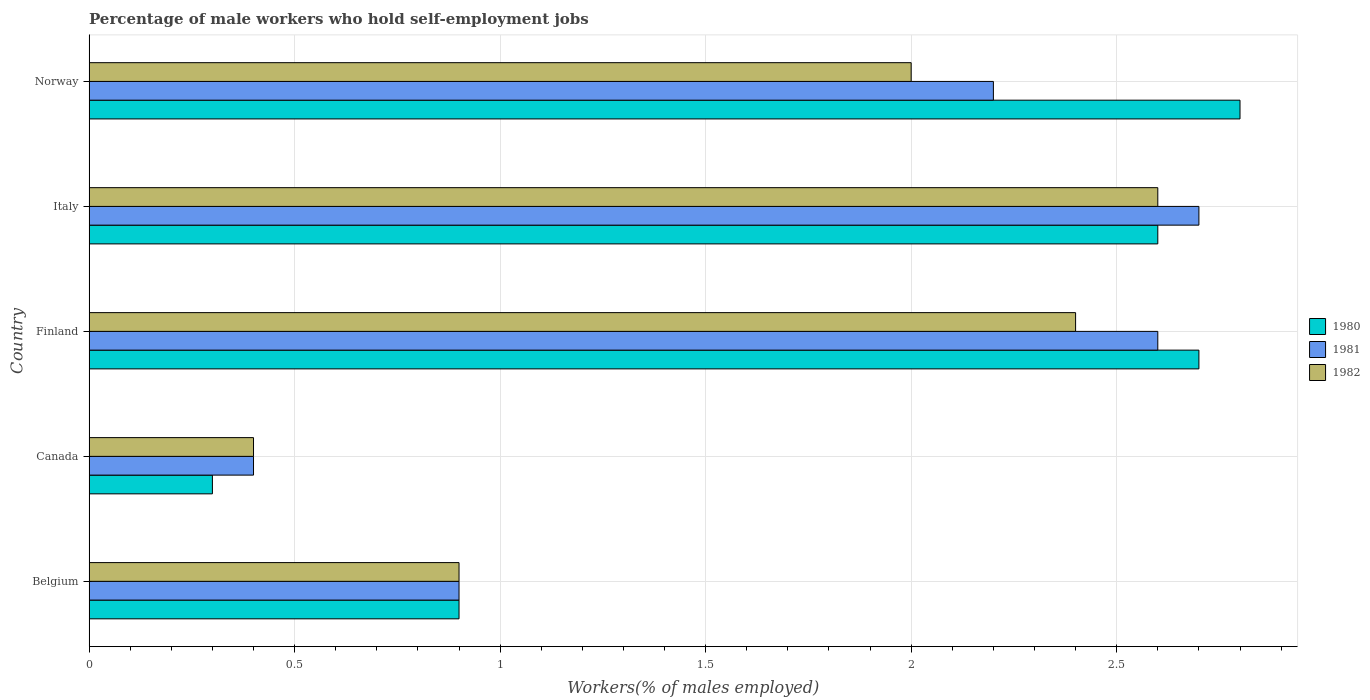How many different coloured bars are there?
Keep it short and to the point. 3. How many groups of bars are there?
Provide a succinct answer. 5. How many bars are there on the 2nd tick from the top?
Offer a terse response. 3. What is the label of the 5th group of bars from the top?
Provide a succinct answer. Belgium. What is the percentage of self-employed male workers in 1982 in Belgium?
Provide a short and direct response. 0.9. Across all countries, what is the maximum percentage of self-employed male workers in 1982?
Provide a succinct answer. 2.6. Across all countries, what is the minimum percentage of self-employed male workers in 1980?
Keep it short and to the point. 0.3. What is the total percentage of self-employed male workers in 1981 in the graph?
Your response must be concise. 8.8. What is the difference between the percentage of self-employed male workers in 1982 in Belgium and that in Norway?
Provide a succinct answer. -1.1. What is the difference between the percentage of self-employed male workers in 1980 in Canada and the percentage of self-employed male workers in 1981 in Belgium?
Your response must be concise. -0.6. What is the average percentage of self-employed male workers in 1980 per country?
Give a very brief answer. 1.86. What is the difference between the percentage of self-employed male workers in 1980 and percentage of self-employed male workers in 1982 in Italy?
Ensure brevity in your answer.  0. What is the ratio of the percentage of self-employed male workers in 1982 in Canada to that in Finland?
Offer a very short reply. 0.17. Is the percentage of self-employed male workers in 1982 in Belgium less than that in Norway?
Provide a short and direct response. Yes. What is the difference between the highest and the second highest percentage of self-employed male workers in 1980?
Ensure brevity in your answer.  0.1. What is the difference between the highest and the lowest percentage of self-employed male workers in 1980?
Ensure brevity in your answer.  2.5. What does the 3rd bar from the top in Norway represents?
Ensure brevity in your answer.  1980. Is it the case that in every country, the sum of the percentage of self-employed male workers in 1980 and percentage of self-employed male workers in 1982 is greater than the percentage of self-employed male workers in 1981?
Offer a very short reply. Yes. How many countries are there in the graph?
Make the answer very short. 5. Are the values on the major ticks of X-axis written in scientific E-notation?
Your answer should be compact. No. Does the graph contain any zero values?
Make the answer very short. No. What is the title of the graph?
Provide a short and direct response. Percentage of male workers who hold self-employment jobs. What is the label or title of the X-axis?
Provide a succinct answer. Workers(% of males employed). What is the Workers(% of males employed) of 1980 in Belgium?
Give a very brief answer. 0.9. What is the Workers(% of males employed) in 1981 in Belgium?
Your answer should be compact. 0.9. What is the Workers(% of males employed) in 1982 in Belgium?
Provide a short and direct response. 0.9. What is the Workers(% of males employed) of 1980 in Canada?
Your answer should be compact. 0.3. What is the Workers(% of males employed) of 1981 in Canada?
Keep it short and to the point. 0.4. What is the Workers(% of males employed) of 1982 in Canada?
Give a very brief answer. 0.4. What is the Workers(% of males employed) of 1980 in Finland?
Offer a terse response. 2.7. What is the Workers(% of males employed) in 1981 in Finland?
Offer a terse response. 2.6. What is the Workers(% of males employed) in 1982 in Finland?
Keep it short and to the point. 2.4. What is the Workers(% of males employed) in 1980 in Italy?
Provide a short and direct response. 2.6. What is the Workers(% of males employed) in 1981 in Italy?
Your answer should be compact. 2.7. What is the Workers(% of males employed) in 1982 in Italy?
Your response must be concise. 2.6. What is the Workers(% of males employed) in 1980 in Norway?
Ensure brevity in your answer.  2.8. What is the Workers(% of males employed) in 1981 in Norway?
Make the answer very short. 2.2. What is the Workers(% of males employed) in 1982 in Norway?
Provide a short and direct response. 2. Across all countries, what is the maximum Workers(% of males employed) of 1980?
Your answer should be very brief. 2.8. Across all countries, what is the maximum Workers(% of males employed) of 1981?
Offer a terse response. 2.7. Across all countries, what is the maximum Workers(% of males employed) of 1982?
Ensure brevity in your answer.  2.6. Across all countries, what is the minimum Workers(% of males employed) of 1980?
Your answer should be very brief. 0.3. Across all countries, what is the minimum Workers(% of males employed) in 1981?
Your answer should be very brief. 0.4. Across all countries, what is the minimum Workers(% of males employed) of 1982?
Ensure brevity in your answer.  0.4. What is the total Workers(% of males employed) of 1981 in the graph?
Ensure brevity in your answer.  8.8. What is the total Workers(% of males employed) of 1982 in the graph?
Keep it short and to the point. 8.3. What is the difference between the Workers(% of males employed) of 1981 in Belgium and that in Canada?
Keep it short and to the point. 0.5. What is the difference between the Workers(% of males employed) in 1981 in Belgium and that in Finland?
Your answer should be compact. -1.7. What is the difference between the Workers(% of males employed) of 1982 in Belgium and that in Italy?
Ensure brevity in your answer.  -1.7. What is the difference between the Workers(% of males employed) of 1980 in Belgium and that in Norway?
Give a very brief answer. -1.9. What is the difference between the Workers(% of males employed) in 1982 in Belgium and that in Norway?
Provide a succinct answer. -1.1. What is the difference between the Workers(% of males employed) of 1980 in Canada and that in Finland?
Your answer should be very brief. -2.4. What is the difference between the Workers(% of males employed) of 1981 in Canada and that in Finland?
Give a very brief answer. -2.2. What is the difference between the Workers(% of males employed) in 1982 in Canada and that in Finland?
Your answer should be compact. -2. What is the difference between the Workers(% of males employed) of 1980 in Canada and that in Italy?
Your response must be concise. -2.3. What is the difference between the Workers(% of males employed) of 1982 in Canada and that in Italy?
Provide a succinct answer. -2.2. What is the difference between the Workers(% of males employed) in 1980 in Canada and that in Norway?
Offer a terse response. -2.5. What is the difference between the Workers(% of males employed) in 1980 in Finland and that in Italy?
Provide a succinct answer. 0.1. What is the difference between the Workers(% of males employed) in 1981 in Finland and that in Italy?
Provide a short and direct response. -0.1. What is the difference between the Workers(% of males employed) of 1982 in Finland and that in Italy?
Provide a succinct answer. -0.2. What is the difference between the Workers(% of males employed) of 1980 in Finland and that in Norway?
Your response must be concise. -0.1. What is the difference between the Workers(% of males employed) of 1982 in Finland and that in Norway?
Provide a short and direct response. 0.4. What is the difference between the Workers(% of males employed) in 1980 in Belgium and the Workers(% of males employed) in 1982 in Canada?
Provide a succinct answer. 0.5. What is the difference between the Workers(% of males employed) of 1981 in Belgium and the Workers(% of males employed) of 1982 in Canada?
Your answer should be very brief. 0.5. What is the difference between the Workers(% of males employed) in 1980 in Belgium and the Workers(% of males employed) in 1981 in Norway?
Offer a terse response. -1.3. What is the difference between the Workers(% of males employed) of 1981 in Belgium and the Workers(% of males employed) of 1982 in Norway?
Your answer should be very brief. -1.1. What is the difference between the Workers(% of males employed) in 1980 in Canada and the Workers(% of males employed) in 1982 in Finland?
Offer a terse response. -2.1. What is the difference between the Workers(% of males employed) of 1981 in Canada and the Workers(% of males employed) of 1982 in Finland?
Offer a terse response. -2. What is the difference between the Workers(% of males employed) of 1981 in Canada and the Workers(% of males employed) of 1982 in Italy?
Offer a terse response. -2.2. What is the difference between the Workers(% of males employed) in 1980 in Canada and the Workers(% of males employed) in 1981 in Norway?
Make the answer very short. -1.9. What is the difference between the Workers(% of males employed) in 1980 in Canada and the Workers(% of males employed) in 1982 in Norway?
Provide a short and direct response. -1.7. What is the difference between the Workers(% of males employed) of 1981 in Canada and the Workers(% of males employed) of 1982 in Norway?
Offer a very short reply. -1.6. What is the difference between the Workers(% of males employed) in 1981 in Finland and the Workers(% of males employed) in 1982 in Italy?
Provide a succinct answer. 0. What is the difference between the Workers(% of males employed) of 1980 in Finland and the Workers(% of males employed) of 1981 in Norway?
Provide a succinct answer. 0.5. What is the difference between the Workers(% of males employed) in 1980 in Finland and the Workers(% of males employed) in 1982 in Norway?
Provide a succinct answer. 0.7. What is the difference between the Workers(% of males employed) in 1981 in Finland and the Workers(% of males employed) in 1982 in Norway?
Ensure brevity in your answer.  0.6. What is the difference between the Workers(% of males employed) in 1980 in Italy and the Workers(% of males employed) in 1981 in Norway?
Keep it short and to the point. 0.4. What is the average Workers(% of males employed) of 1980 per country?
Your answer should be compact. 1.86. What is the average Workers(% of males employed) of 1981 per country?
Provide a short and direct response. 1.76. What is the average Workers(% of males employed) in 1982 per country?
Keep it short and to the point. 1.66. What is the difference between the Workers(% of males employed) of 1981 and Workers(% of males employed) of 1982 in Belgium?
Your answer should be compact. 0. What is the difference between the Workers(% of males employed) of 1980 and Workers(% of males employed) of 1982 in Canada?
Give a very brief answer. -0.1. What is the difference between the Workers(% of males employed) in 1981 and Workers(% of males employed) in 1982 in Canada?
Your response must be concise. 0. What is the difference between the Workers(% of males employed) in 1980 and Workers(% of males employed) in 1981 in Finland?
Provide a short and direct response. 0.1. What is the difference between the Workers(% of males employed) in 1980 and Workers(% of males employed) in 1982 in Finland?
Give a very brief answer. 0.3. What is the difference between the Workers(% of males employed) of 1980 and Workers(% of males employed) of 1981 in Italy?
Offer a terse response. -0.1. What is the difference between the Workers(% of males employed) of 1981 and Workers(% of males employed) of 1982 in Italy?
Offer a very short reply. 0.1. What is the difference between the Workers(% of males employed) of 1980 and Workers(% of males employed) of 1982 in Norway?
Your answer should be compact. 0.8. What is the ratio of the Workers(% of males employed) of 1980 in Belgium to that in Canada?
Offer a very short reply. 3. What is the ratio of the Workers(% of males employed) of 1981 in Belgium to that in Canada?
Your response must be concise. 2.25. What is the ratio of the Workers(% of males employed) of 1982 in Belgium to that in Canada?
Give a very brief answer. 2.25. What is the ratio of the Workers(% of males employed) of 1981 in Belgium to that in Finland?
Your response must be concise. 0.35. What is the ratio of the Workers(% of males employed) of 1982 in Belgium to that in Finland?
Your response must be concise. 0.38. What is the ratio of the Workers(% of males employed) in 1980 in Belgium to that in Italy?
Ensure brevity in your answer.  0.35. What is the ratio of the Workers(% of males employed) in 1981 in Belgium to that in Italy?
Make the answer very short. 0.33. What is the ratio of the Workers(% of males employed) in 1982 in Belgium to that in Italy?
Ensure brevity in your answer.  0.35. What is the ratio of the Workers(% of males employed) in 1980 in Belgium to that in Norway?
Provide a succinct answer. 0.32. What is the ratio of the Workers(% of males employed) in 1981 in Belgium to that in Norway?
Offer a very short reply. 0.41. What is the ratio of the Workers(% of males employed) in 1982 in Belgium to that in Norway?
Offer a terse response. 0.45. What is the ratio of the Workers(% of males employed) of 1980 in Canada to that in Finland?
Offer a very short reply. 0.11. What is the ratio of the Workers(% of males employed) in 1981 in Canada to that in Finland?
Ensure brevity in your answer.  0.15. What is the ratio of the Workers(% of males employed) in 1982 in Canada to that in Finland?
Provide a succinct answer. 0.17. What is the ratio of the Workers(% of males employed) of 1980 in Canada to that in Italy?
Your answer should be compact. 0.12. What is the ratio of the Workers(% of males employed) in 1981 in Canada to that in Italy?
Ensure brevity in your answer.  0.15. What is the ratio of the Workers(% of males employed) of 1982 in Canada to that in Italy?
Offer a terse response. 0.15. What is the ratio of the Workers(% of males employed) of 1980 in Canada to that in Norway?
Give a very brief answer. 0.11. What is the ratio of the Workers(% of males employed) of 1981 in Canada to that in Norway?
Offer a terse response. 0.18. What is the ratio of the Workers(% of males employed) of 1980 in Finland to that in Italy?
Offer a terse response. 1.04. What is the ratio of the Workers(% of males employed) in 1982 in Finland to that in Italy?
Make the answer very short. 0.92. What is the ratio of the Workers(% of males employed) of 1981 in Finland to that in Norway?
Make the answer very short. 1.18. What is the ratio of the Workers(% of males employed) in 1982 in Finland to that in Norway?
Provide a short and direct response. 1.2. What is the ratio of the Workers(% of males employed) of 1980 in Italy to that in Norway?
Give a very brief answer. 0.93. What is the ratio of the Workers(% of males employed) in 1981 in Italy to that in Norway?
Give a very brief answer. 1.23. What is the ratio of the Workers(% of males employed) of 1982 in Italy to that in Norway?
Your response must be concise. 1.3. What is the difference between the highest and the lowest Workers(% of males employed) in 1980?
Provide a succinct answer. 2.5. What is the difference between the highest and the lowest Workers(% of males employed) in 1982?
Ensure brevity in your answer.  2.2. 